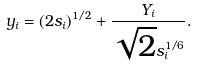Convert formula to latex. <formula><loc_0><loc_0><loc_500><loc_500>y _ { i } = ( 2 s _ { i } ) ^ { 1 / 2 } + \frac { Y _ { i } } { \sqrt { 2 } s _ { i } ^ { 1 / 6 } } .</formula> 